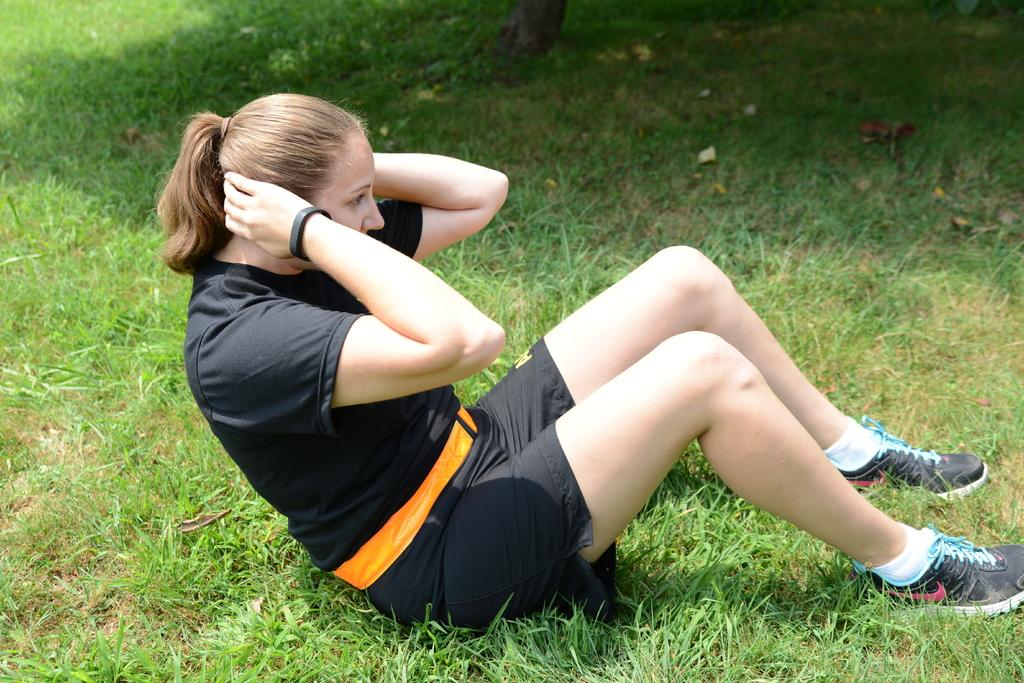Who is present in the image? There is a woman in the image. What is the woman standing on? The woman is on grass in the image. Where might this image have been taken? The image appears to be taken in a park. What time of day is it in the image? The time of day is likely to be during the day. Reasoning: Let' Let's think step by step in order to produce the conversation. We start by identifying the main subject in the image, which is the woman. Then, we describe the setting and context of the image, including the grass and the park. Finally, we make an educated guess about the time of day based on the available information. Absurd Question/Answer: What type of swim is the woman performing in the image? There is no swim or swimming activity depicted in the image; the woman is standing on grass in a park. 